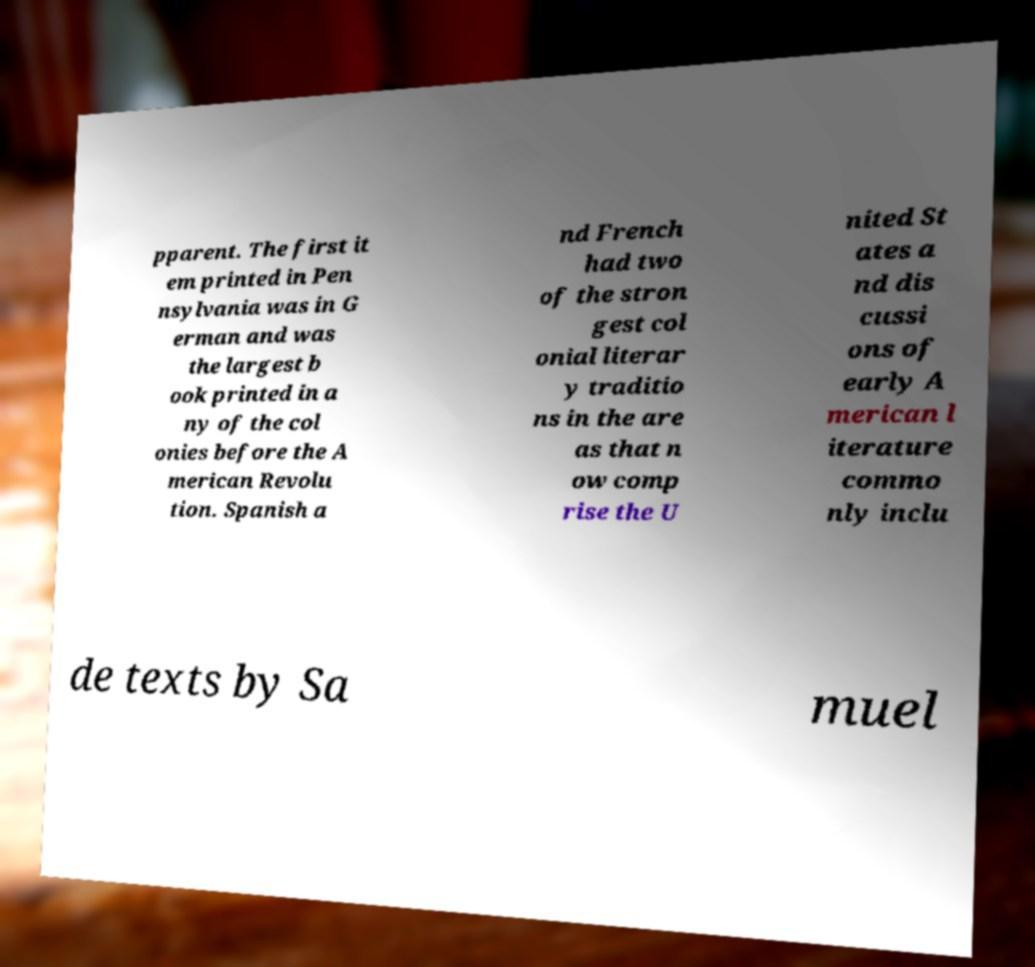Can you accurately transcribe the text from the provided image for me? pparent. The first it em printed in Pen nsylvania was in G erman and was the largest b ook printed in a ny of the col onies before the A merican Revolu tion. Spanish a nd French had two of the stron gest col onial literar y traditio ns in the are as that n ow comp rise the U nited St ates a nd dis cussi ons of early A merican l iterature commo nly inclu de texts by Sa muel 